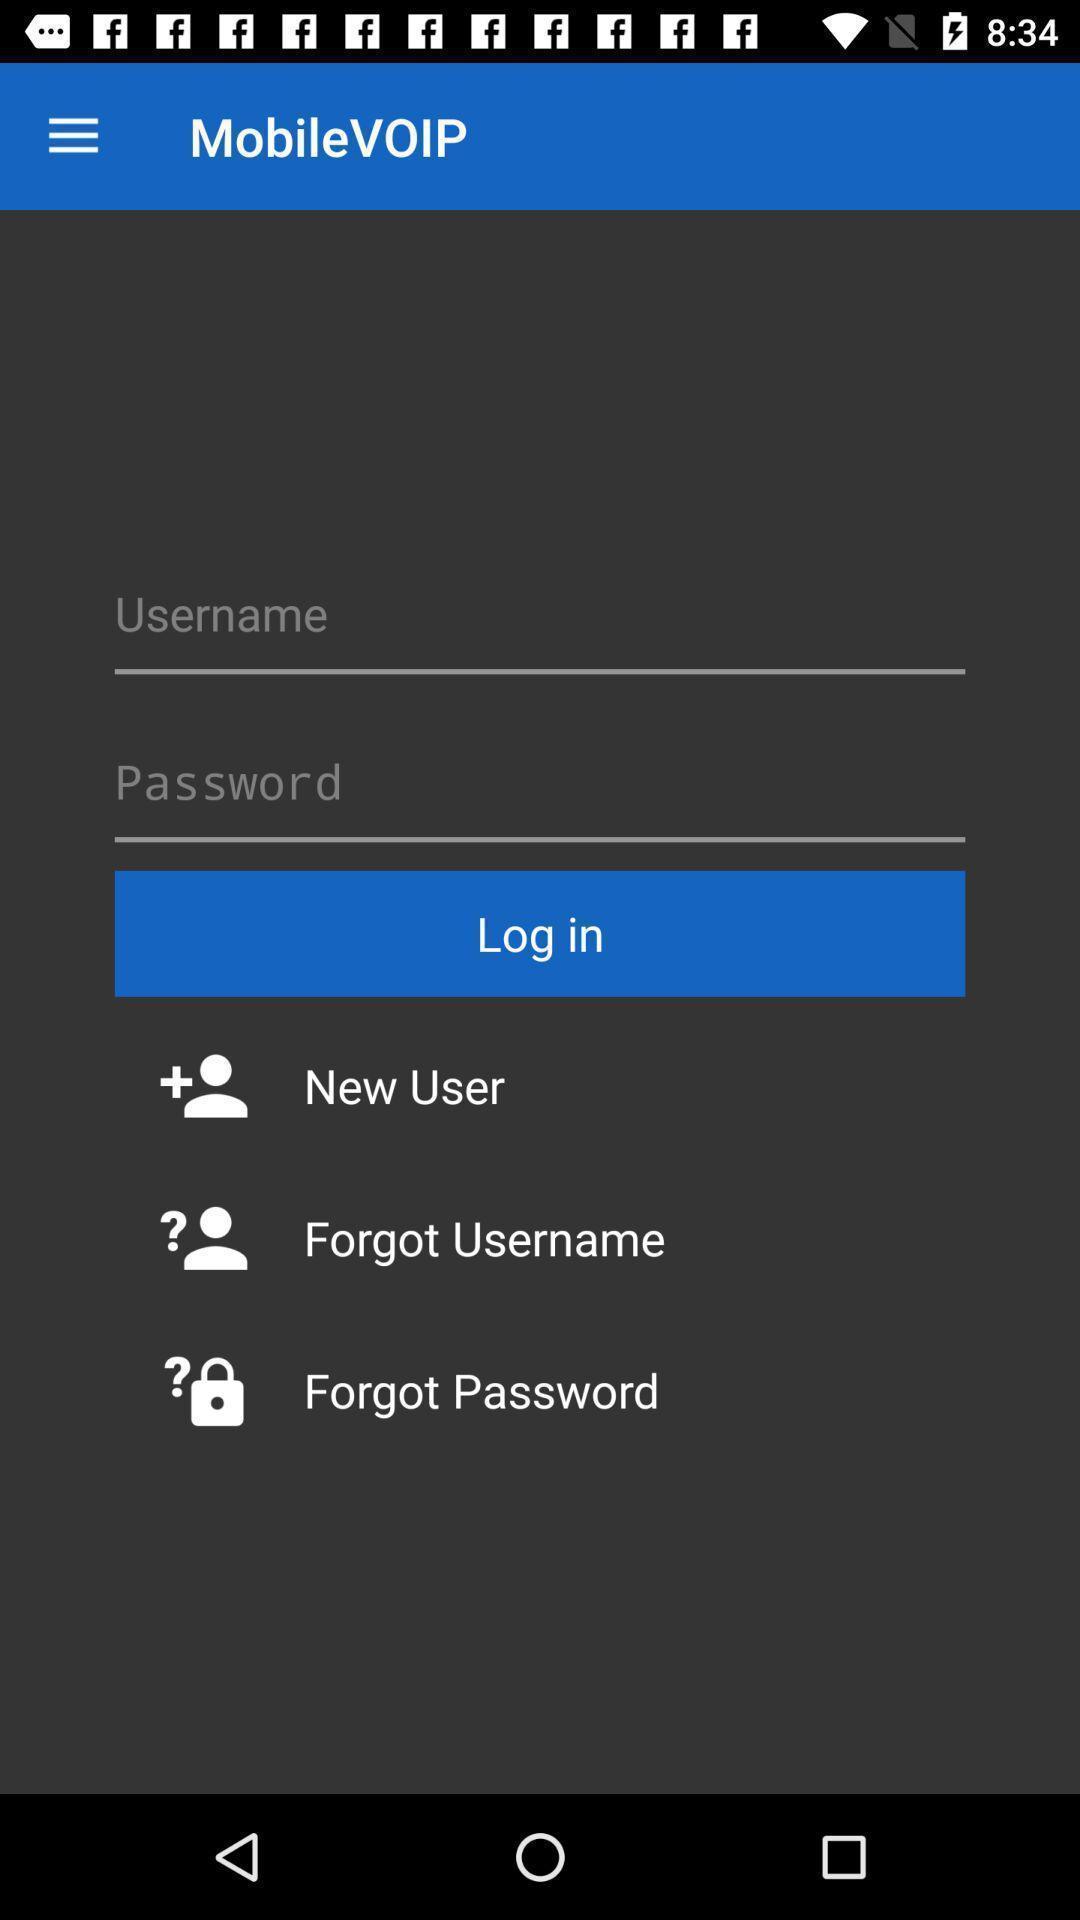Explain the elements present in this screenshot. Login page for international calling app. 